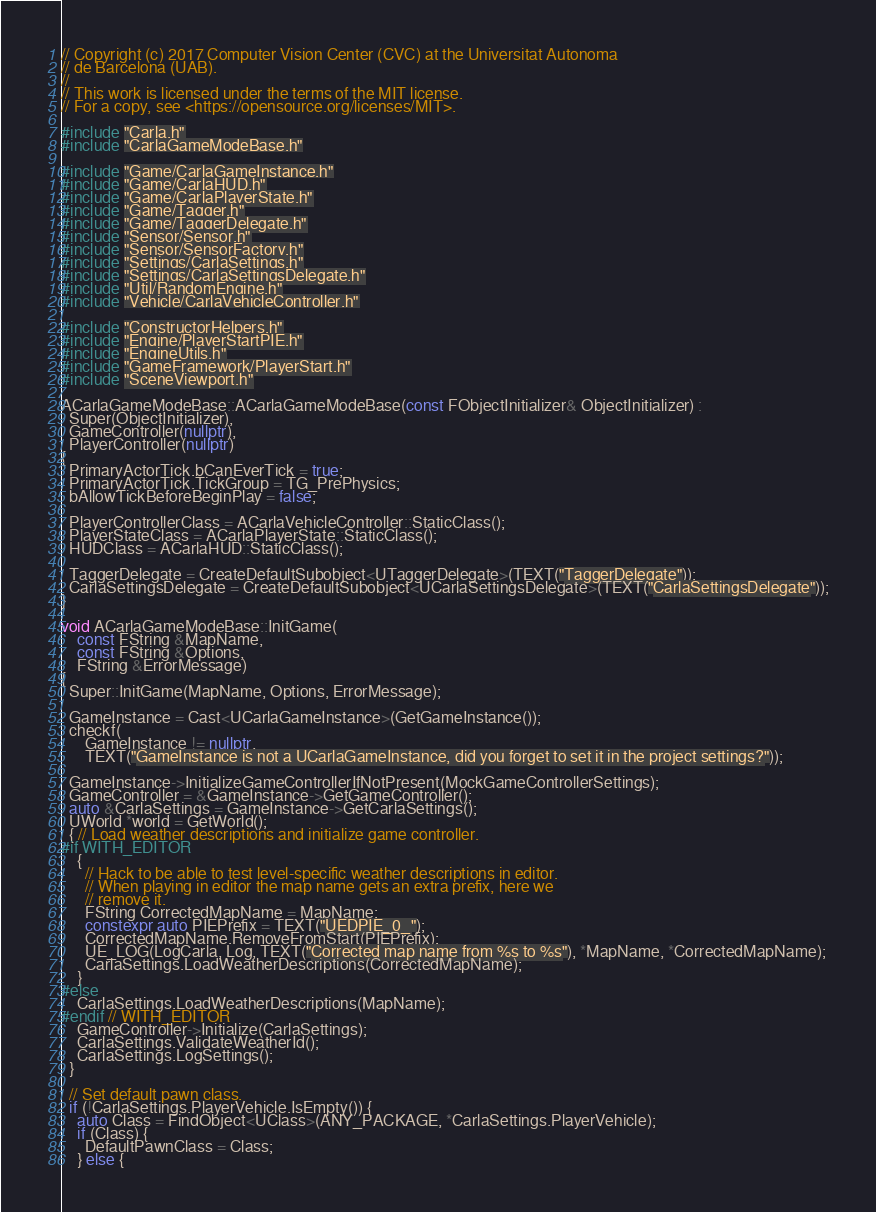Convert code to text. <code><loc_0><loc_0><loc_500><loc_500><_C++_>// Copyright (c) 2017 Computer Vision Center (CVC) at the Universitat Autonoma
// de Barcelona (UAB).
//
// This work is licensed under the terms of the MIT license.
// For a copy, see <https://opensource.org/licenses/MIT>.

#include "Carla.h"
#include "CarlaGameModeBase.h"

#include "Game/CarlaGameInstance.h"
#include "Game/CarlaHUD.h"
#include "Game/CarlaPlayerState.h"
#include "Game/Tagger.h"
#include "Game/TaggerDelegate.h"
#include "Sensor/Sensor.h"
#include "Sensor/SensorFactory.h"
#include "Settings/CarlaSettings.h"
#include "Settings/CarlaSettingsDelegate.h"
#include "Util/RandomEngine.h"
#include "Vehicle/CarlaVehicleController.h"

#include "ConstructorHelpers.h"
#include "Engine/PlayerStartPIE.h"
#include "EngineUtils.h"
#include "GameFramework/PlayerStart.h"
#include "SceneViewport.h"

ACarlaGameModeBase::ACarlaGameModeBase(const FObjectInitializer& ObjectInitializer) :
  Super(ObjectInitializer),
  GameController(nullptr),
  PlayerController(nullptr)
{
  PrimaryActorTick.bCanEverTick = true;
  PrimaryActorTick.TickGroup = TG_PrePhysics;
  bAllowTickBeforeBeginPlay = false;

  PlayerControllerClass = ACarlaVehicleController::StaticClass();
  PlayerStateClass = ACarlaPlayerState::StaticClass();
  HUDClass = ACarlaHUD::StaticClass();

  TaggerDelegate = CreateDefaultSubobject<UTaggerDelegate>(TEXT("TaggerDelegate"));
  CarlaSettingsDelegate = CreateDefaultSubobject<UCarlaSettingsDelegate>(TEXT("CarlaSettingsDelegate"));
}

void ACarlaGameModeBase::InitGame(
    const FString &MapName,
    const FString &Options,
    FString &ErrorMessage)
{
  Super::InitGame(MapName, Options, ErrorMessage);

  GameInstance = Cast<UCarlaGameInstance>(GetGameInstance());
  checkf(
      GameInstance != nullptr,
      TEXT("GameInstance is not a UCarlaGameInstance, did you forget to set it in the project settings?"));

  GameInstance->InitializeGameControllerIfNotPresent(MockGameControllerSettings);
  GameController = &GameInstance->GetGameController();
  auto &CarlaSettings = GameInstance->GetCarlaSettings();
  UWorld *world = GetWorld();
  { // Load weather descriptions and initialize game controller.
#if WITH_EDITOR
    {
      // Hack to be able to test level-specific weather descriptions in editor.
      // When playing in editor the map name gets an extra prefix, here we
      // remove it.
      FString CorrectedMapName = MapName;
      constexpr auto PIEPrefix = TEXT("UEDPIE_0_");
      CorrectedMapName.RemoveFromStart(PIEPrefix);
      UE_LOG(LogCarla, Log, TEXT("Corrected map name from %s to %s"), *MapName, *CorrectedMapName);
      CarlaSettings.LoadWeatherDescriptions(CorrectedMapName);
    }
#else
    CarlaSettings.LoadWeatherDescriptions(MapName);
#endif // WITH_EDITOR
    GameController->Initialize(CarlaSettings);
    CarlaSettings.ValidateWeatherId();
    CarlaSettings.LogSettings();
  }

  // Set default pawn class.
  if (!CarlaSettings.PlayerVehicle.IsEmpty()) {
    auto Class = FindObject<UClass>(ANY_PACKAGE, *CarlaSettings.PlayerVehicle);
    if (Class) {
      DefaultPawnClass = Class;
    } else {</code> 